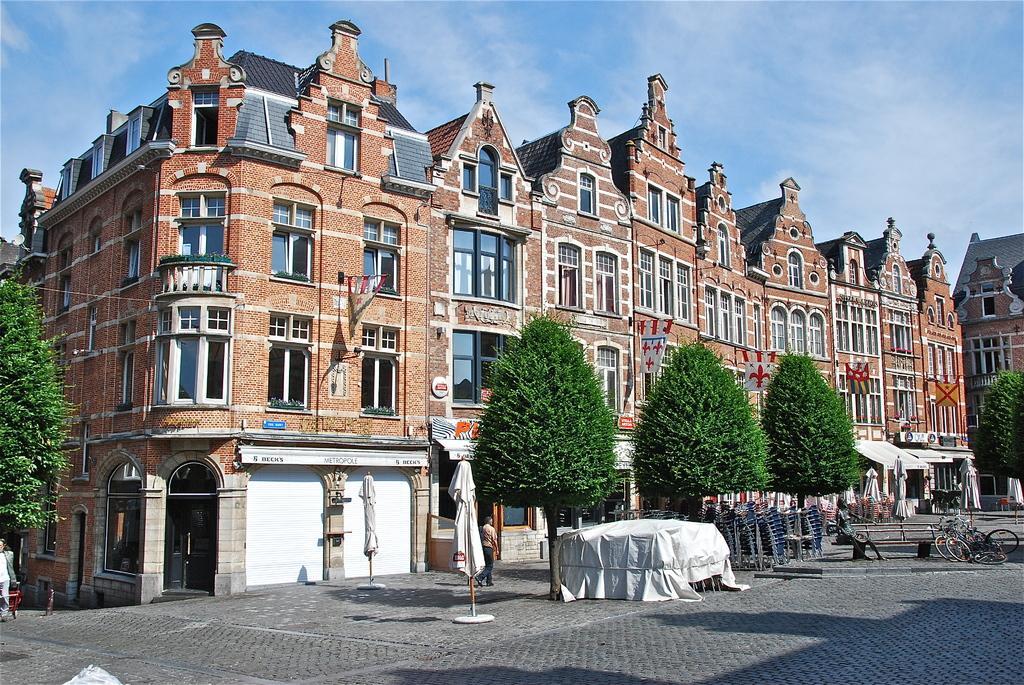How would you summarize this image in a sentence or two? In this image in the center there are some buildings and trees, on the left side there is one tree and also in the center there is one person who is walking. At the bottom there is a walkway, and on the right side there are some cycles. In the center there are some chairs and the chairs are covered with a cloth and also there are some flags and poles. On the left side there are two persons, and on the top of the image there is sky. 